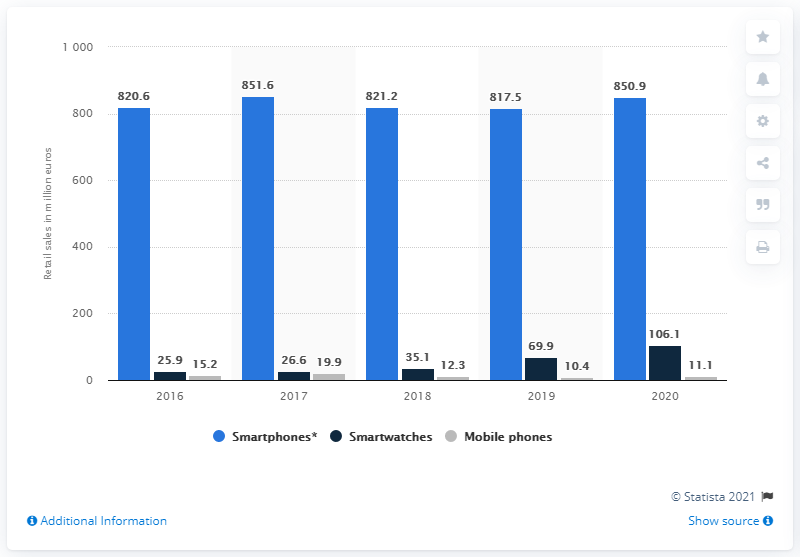Outline some significant characteristics in this image. In 2020, smartwatch sales reached a significant milestone in Finland with a total of 106.1 units sold. 